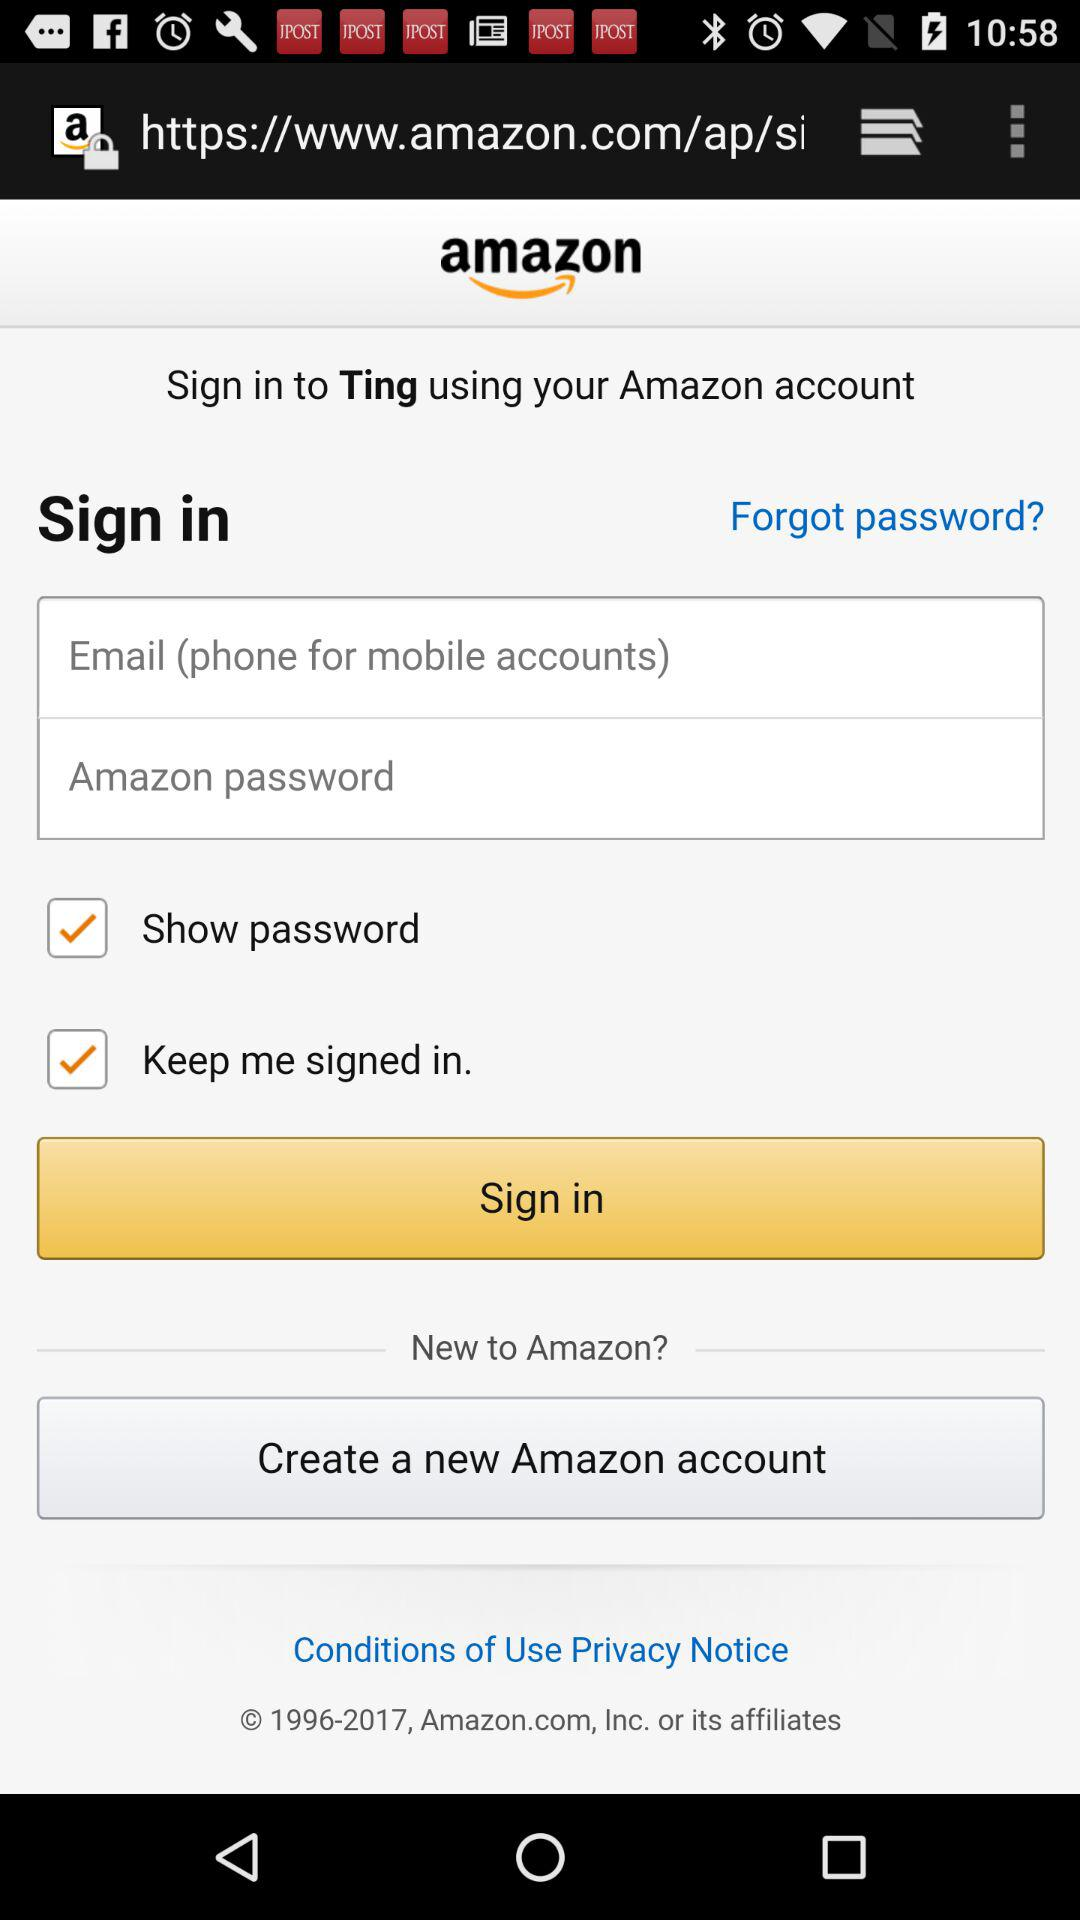Is the "Show password" checked or unchecked? The "Show password" is checked. 